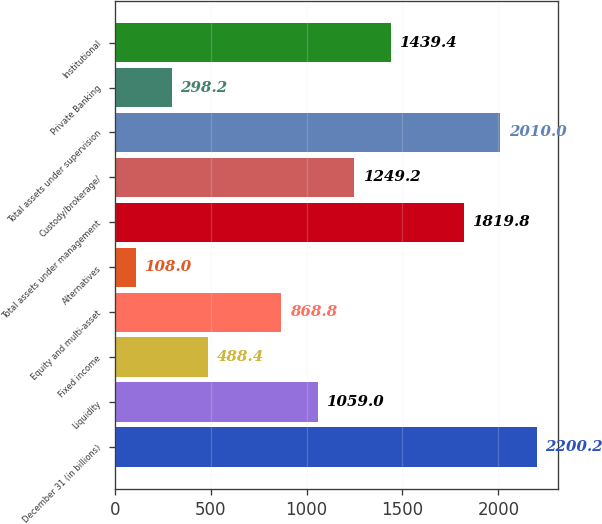Convert chart to OTSL. <chart><loc_0><loc_0><loc_500><loc_500><bar_chart><fcel>December 31 (in billions)<fcel>Liquidity<fcel>Fixed income<fcel>Equity and multi-asset<fcel>Alternatives<fcel>Total assets under management<fcel>Custody/brokerage/<fcel>Total assets under supervision<fcel>Private Banking<fcel>Institutional<nl><fcel>2200.2<fcel>1059<fcel>488.4<fcel>868.8<fcel>108<fcel>1819.8<fcel>1249.2<fcel>2010<fcel>298.2<fcel>1439.4<nl></chart> 